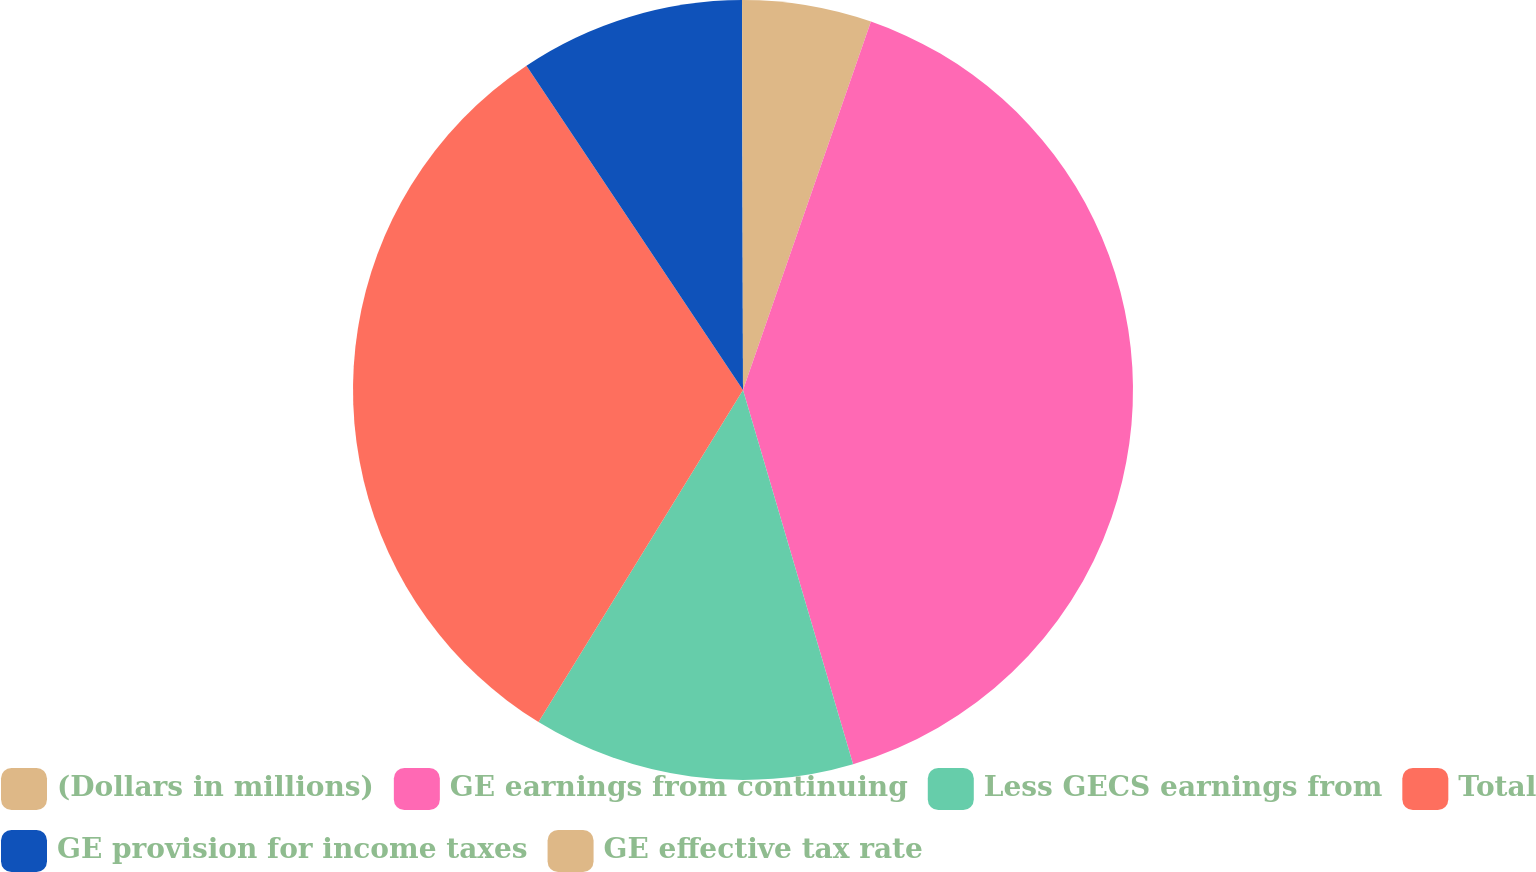Convert chart to OTSL. <chart><loc_0><loc_0><loc_500><loc_500><pie_chart><fcel>(Dollars in millions)<fcel>GE earnings from continuing<fcel>Less GECS earnings from<fcel>Total<fcel>GE provision for income taxes<fcel>GE effective tax rate<nl><fcel>5.32%<fcel>40.13%<fcel>13.34%<fcel>31.85%<fcel>9.33%<fcel>0.04%<nl></chart> 